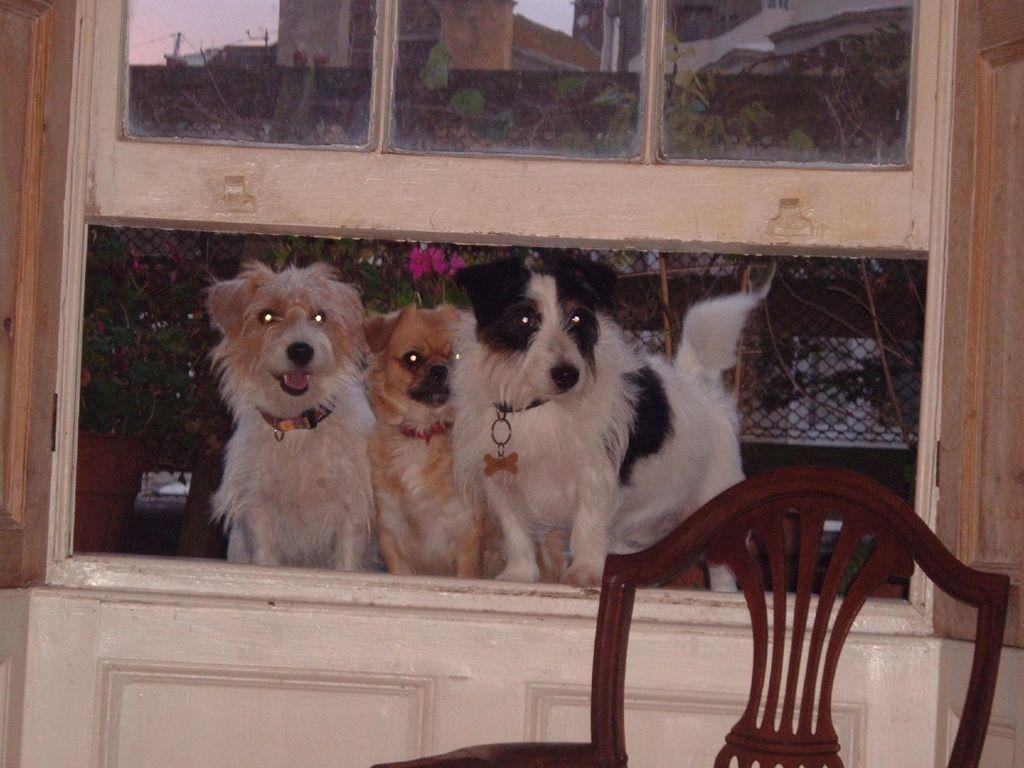Describe this image in one or two sentences. This is the picture taken in a home, on the window there are three dogs are standing. In front of the dogs there is a chair. Behind the dogs there is a fencing and trees and top of the dog is a glass window. 